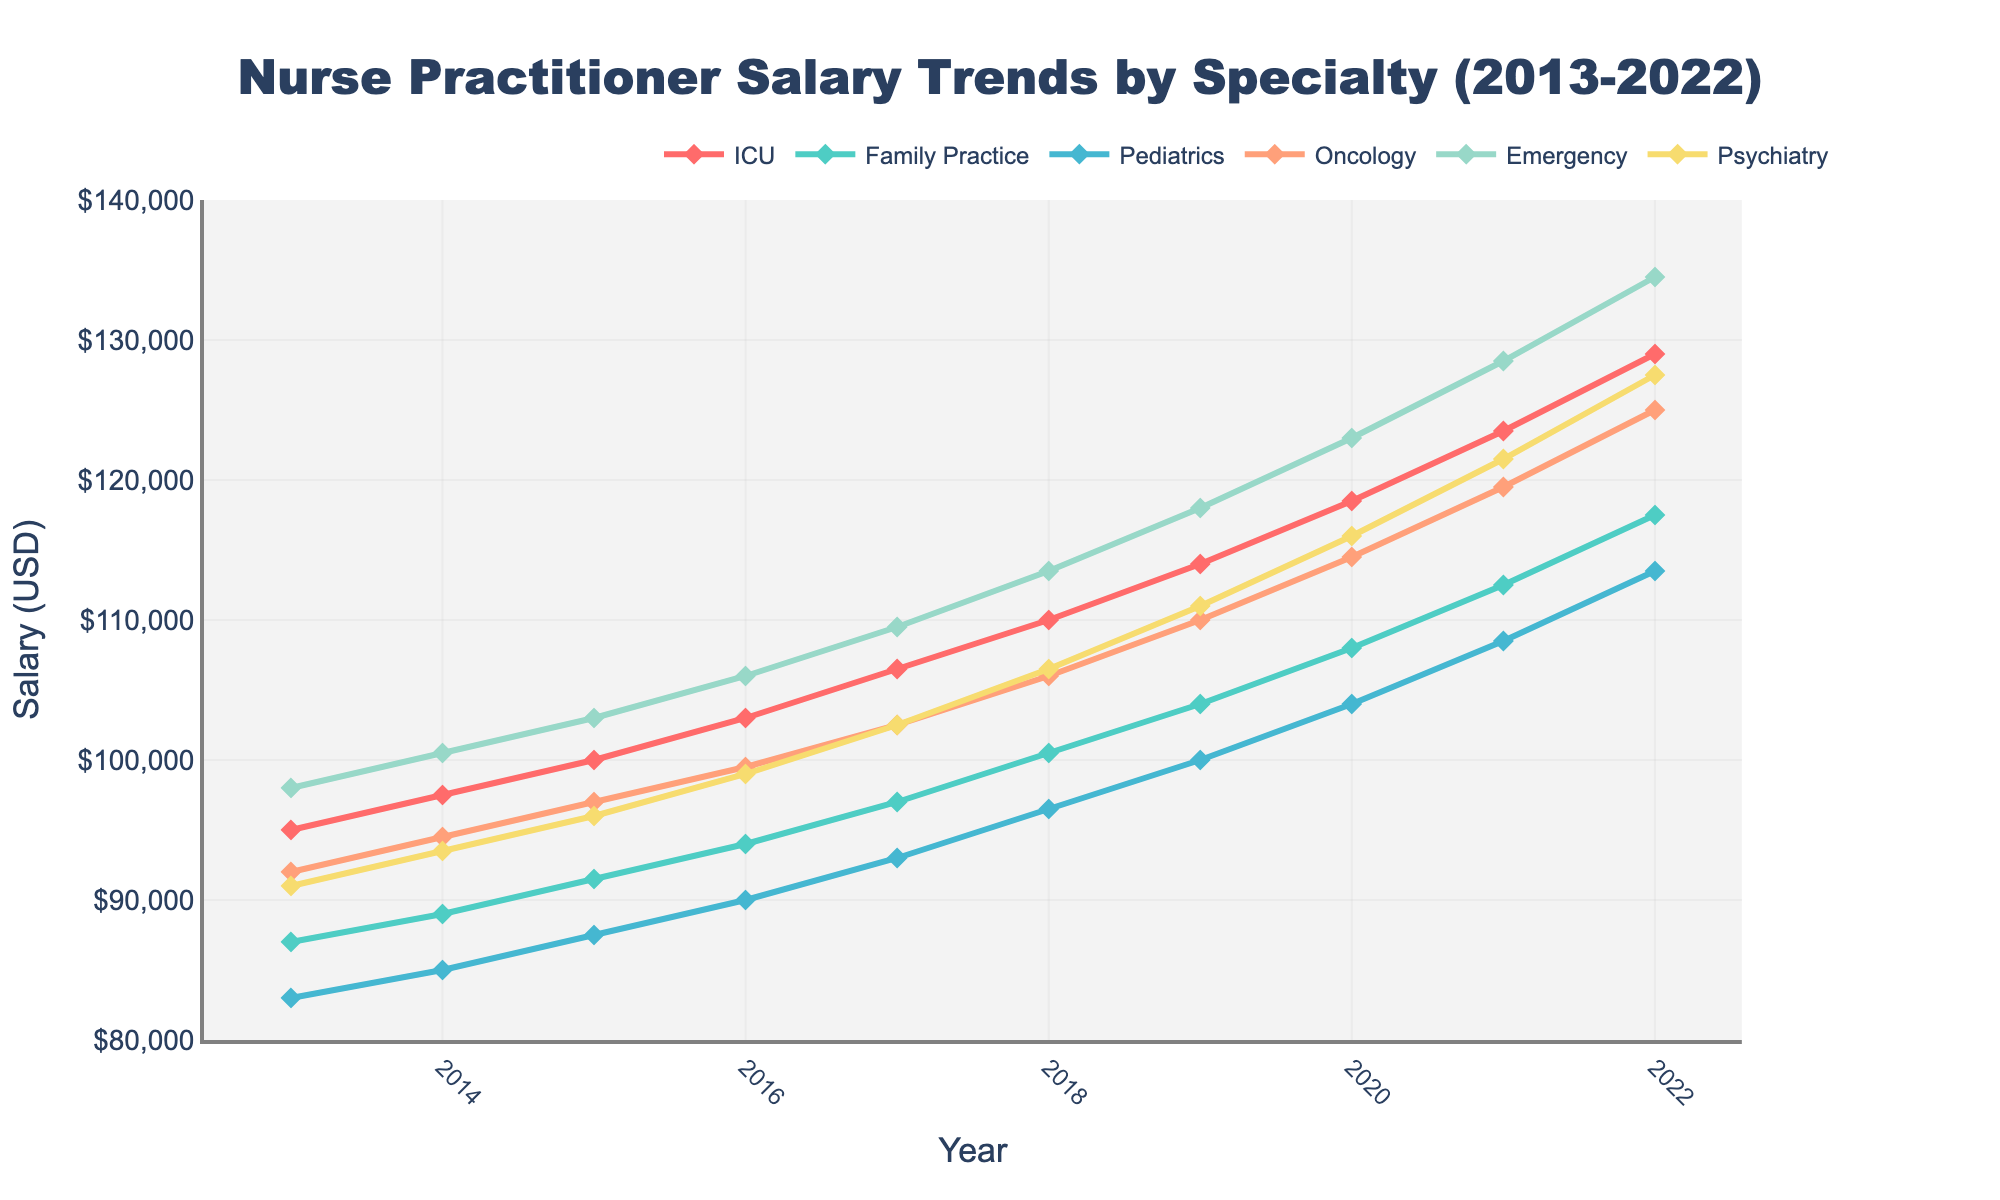What's the salary trend for nurse practitioners in ICU from 2013 to 2022? ICU salaries increased consistently every year, starting at $95,000 in 2013 and reaching $129,000 by 2022.
Answer: Increasing trend Which specialty had the highest salary in 2016? To determine the highest salary specialty in 2016, compare the salaries: ICU ($103,000), Family Practice ($94,000), Pediatrics ($90,000), Oncology ($99,500), Emergency ($106,000), Psychiatry ($99,000). The highest salary is in Emergency.
Answer: Emergency What's the difference in salary between Pediatrics and Emergency specialties in 2022? Subtract the 2022 salary of Pediatrics ($113,500) from Emergency ($134,500): $134,500 - $113,500 = $21,000.
Answer: $21,000 Which two specialties had the smallest salary difference in 2017? Calculate the differences between the salaries for each pair of specialties in 2017: ICU ($106,500), Family Practice ($97,000), Pediatrics ($93,000), Oncology ($102,500), Emergency ($109,500), Psychiatry ($102,500). The smallest difference is between Oncology ($102,500) and Psychiatry ($102,500), with a difference of $0.
Answer: Oncology and Psychiatry What is the average salary of the Family Practice specialty over the entire period? Calculate the sum of Family Practice salaries from 2013 to 2022: $87,000 + $89,000 + $91,500 + $94,000 + $97,000 + $100,500 + $104,000 + $108,000 + $112,500 + $117,500 = $1,001,000. Divide by the number of years (10): $1,001,000 / 10 = $100,100.
Answer: $100,100 By how much did the salary of Psychiatry increase from 2013 to 2022? Subtract the 2013 salary of Psychiatry ($91,000) from the 2022 salary ($127,500): $127,500 - $91,000 = $36,500.
Answer: $36,500 Which specialty had the most significant salary growth between 2013 and 2022? Determine the salary increase for each specialty: 
ICU: $129,000 - $95,000 = $34,000,
Family Practice: $117,500 - $87,000 = $30,500,
Pediatrics: $113,500 - $83,000 = $30,500,
Oncology: $125,000 - $92,000 = $33,000,
Emergency: $134,500 - $98,000 = $36,500,
Psychiatry: $127,500 - $91,000 = $36,500.
The highest growth is in Emergency and Psychiatry, both at $36,500.
Answer: Emergency and Psychiatry What are the two years with the most significant increase in Family Practice salaries? Calculate annual increases for Family Practice:
2014: $89,000 - $87,000 = $2,000,
2015: $91,500 - $89,000 = $2,500,
2016: $94,000 - $91,500 = $2,500,
2017: $97,000 - $94,000 = $3,000,
2018: $100,500 - $97,000 = $3,500,
2019: $104,000 - $100,500 = $3,500,
2020: $108,000 - $104,000 = $4,000,
2021: $112,500 - $108,000 = $4,500,
2022: $117,500 - $112,500 = $5,000.
The most significant increases occur in 2021 ($4,500) and 2022 ($5,000).
Answer: 2021 and 2022 What is the average salary across all specialties in 2020? Sum up the 2020 salaries: $118,500 (ICU) + $108,000 (Family Practice) + $104,000 (Pediatrics) + $114,500 (Oncology) + $123,000 (Emergency) + $116,000 (Psychiatry) = $684,000. Divide by the number of specialties (6): $684,000 / 6 = $114,000.
Answer: $114,000 